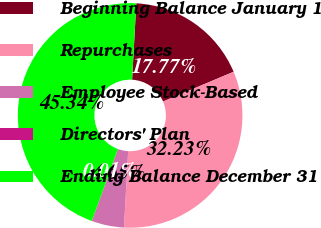Convert chart to OTSL. <chart><loc_0><loc_0><loc_500><loc_500><pie_chart><fcel>Beginning Balance January 1<fcel>Repurchases<fcel>Employee Stock-Based<fcel>Directors' Plan<fcel>Ending Balance December 31<nl><fcel>17.77%<fcel>32.23%<fcel>4.65%<fcel>0.01%<fcel>45.34%<nl></chart> 